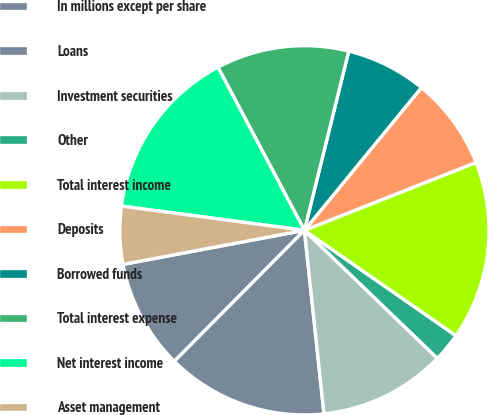Convert chart. <chart><loc_0><loc_0><loc_500><loc_500><pie_chart><fcel>In millions except per share<fcel>Loans<fcel>Investment securities<fcel>Other<fcel>Total interest income<fcel>Deposits<fcel>Borrowed funds<fcel>Total interest expense<fcel>Net interest income<fcel>Asset management<nl><fcel>9.6%<fcel>14.14%<fcel>11.11%<fcel>2.53%<fcel>15.66%<fcel>8.08%<fcel>7.07%<fcel>11.62%<fcel>15.15%<fcel>5.05%<nl></chart> 